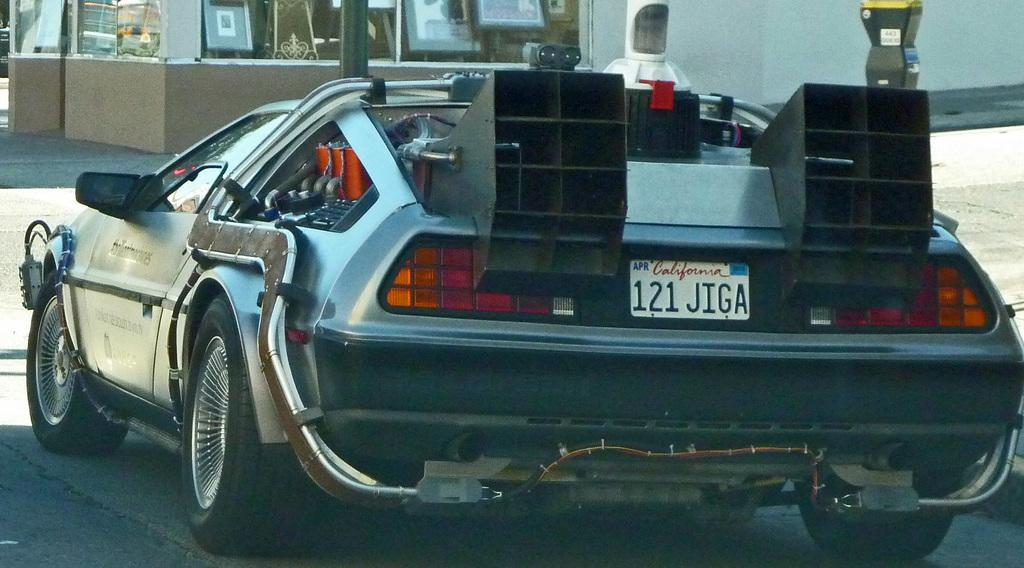What is the main subject in the foreground of the picture? There is a car in the foreground of the picture. What can be seen in the background of the picture? There is a building, frames, a wall, and a road in the background of the picture. What type of popcorn is being served at the war depicted in the image? There is no war or popcorn present in the image; it features a car in the foreground and various elements in the background. 